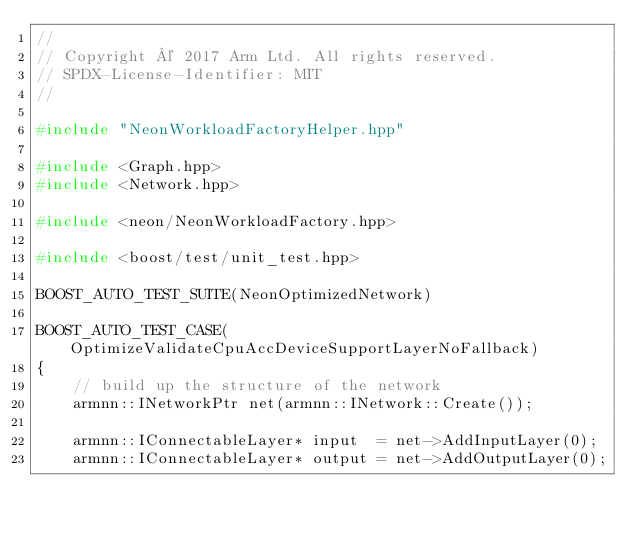<code> <loc_0><loc_0><loc_500><loc_500><_C++_>//
// Copyright © 2017 Arm Ltd. All rights reserved.
// SPDX-License-Identifier: MIT
//

#include "NeonWorkloadFactoryHelper.hpp"

#include <Graph.hpp>
#include <Network.hpp>

#include <neon/NeonWorkloadFactory.hpp>

#include <boost/test/unit_test.hpp>

BOOST_AUTO_TEST_SUITE(NeonOptimizedNetwork)

BOOST_AUTO_TEST_CASE(OptimizeValidateCpuAccDeviceSupportLayerNoFallback)
{
    // build up the structure of the network
    armnn::INetworkPtr net(armnn::INetwork::Create());

    armnn::IConnectableLayer* input  = net->AddInputLayer(0);
    armnn::IConnectableLayer* output = net->AddOutputLayer(0);
</code> 